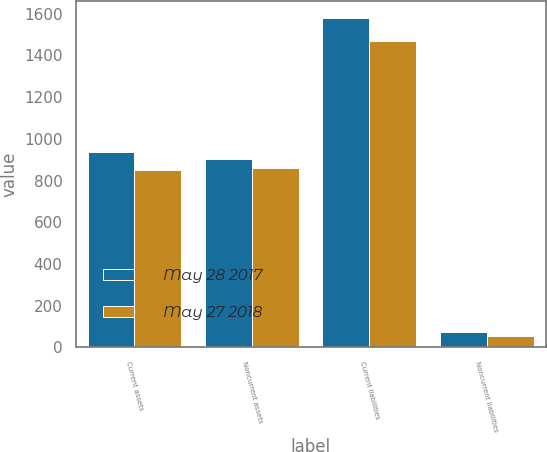Convert chart. <chart><loc_0><loc_0><loc_500><loc_500><stacked_bar_chart><ecel><fcel>Current assets<fcel>Noncurrent assets<fcel>Current liabilities<fcel>Noncurrent liabilities<nl><fcel>May 28 2017<fcel>938.5<fcel>902.5<fcel>1579.3<fcel>72.6<nl><fcel>May 27 2018<fcel>849.7<fcel>858.9<fcel>1469.6<fcel>55.2<nl></chart> 